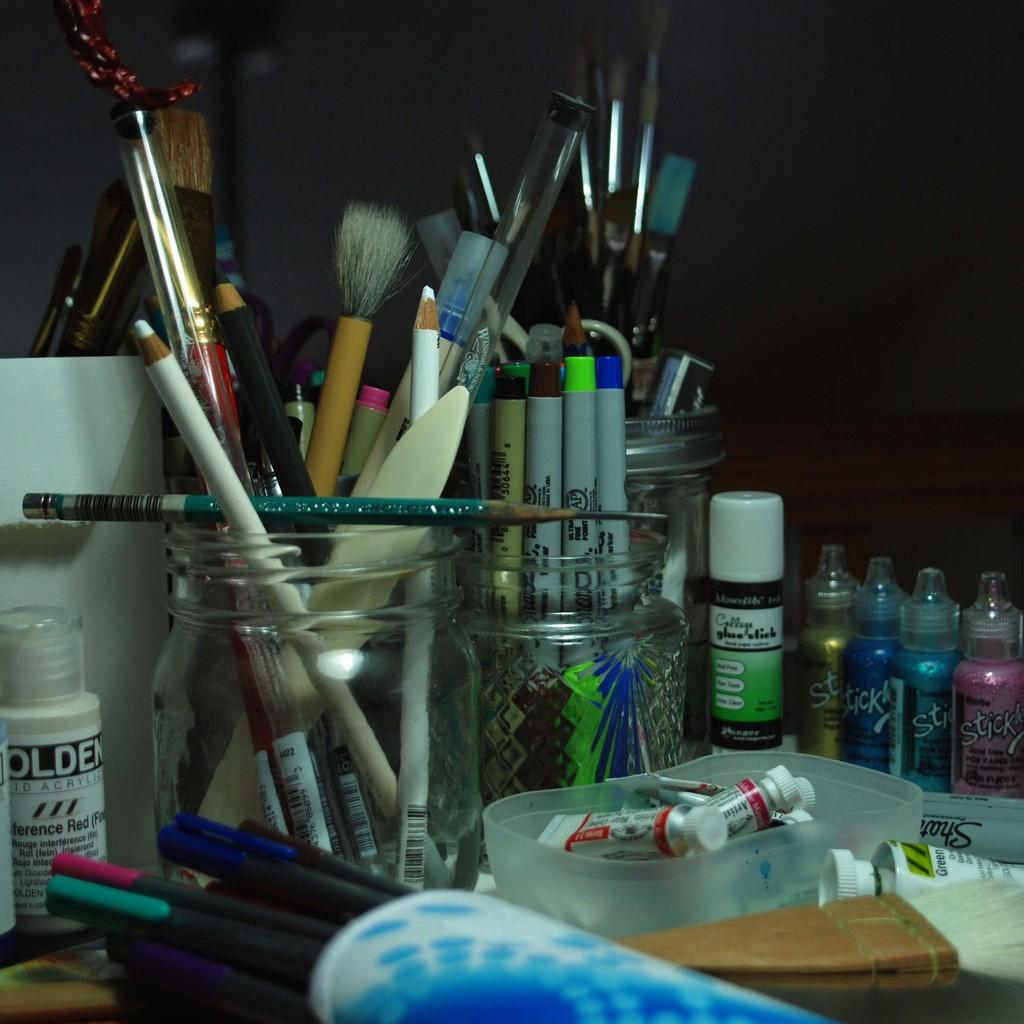<image>
Share a concise interpretation of the image provided. A collection of brushes and sharpie branded pens siting in jars. 